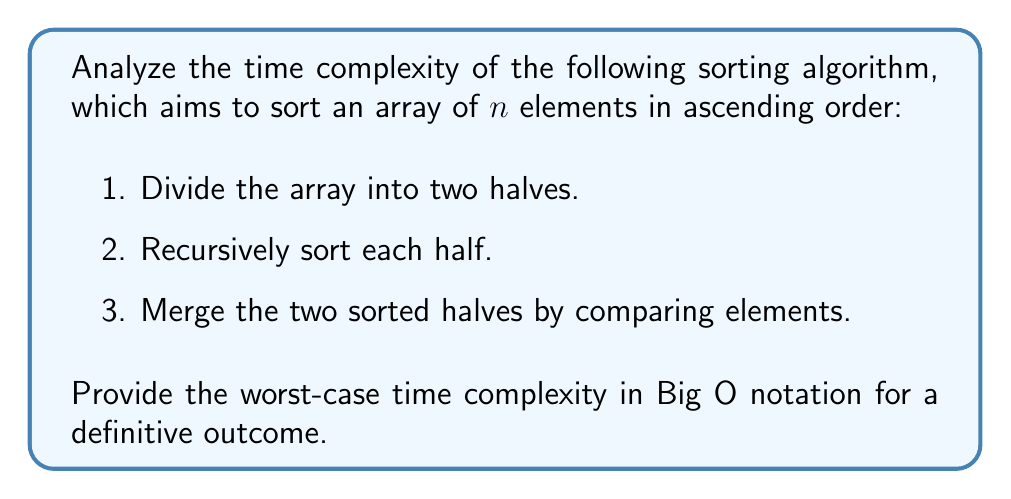Solve this math problem. Let's analyze this algorithm step by step:

1. Dividing the array: This step takes constant time, $O(1)$.

2. Recursive sorting: The algorithm recursively divides the array until we have subarrays of size 1. This creates a recursion tree with $\log_2 n$ levels.

3. Merging: At each level of the recursion tree, we merge subarrays. The total number of elements merged at each level is n.

To calculate the time complexity, we need to sum up the work done at each level:

$$T(n) = 2T(n/2) + O(n)$$

This recurrence relation describes the merge sort algorithm. We can solve it using the Master Theorem:

$$T(n) = aT(n/b) + f(n)$$

Where:
$a = 2$ (number of recursive calls)
$b = 2$ (size reduction factor)
$f(n) = O(n)$ (work done outside recursive calls)

Comparing $n^{\log_b a}$ with $f(n)$:

$$n^{\log_2 2} = n^1 = n = f(n)$$

Since $n^{\log_b a} = f(n)$, we fall into case 2 of the Master Theorem:

$$T(n) = \Theta(n^{\log_b a} \log n) = \Theta(n \log n)$$

Therefore, the worst-case time complexity of this algorithm is $O(n \log n)$.

This analysis provides a definitive outcome, as the time complexity is precisely determined and doesn't depend on the input distribution.
Answer: The worst-case time complexity of the given sorting algorithm is $O(n \log n)$. 